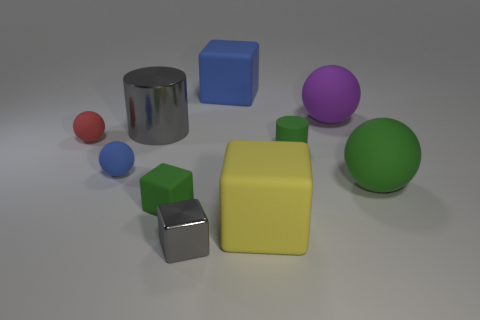Subtract all red balls. How many balls are left? 3 Subtract all gray blocks. How many blocks are left? 3 Subtract all yellow balls. Subtract all brown cylinders. How many balls are left? 4 Subtract all spheres. How many objects are left? 6 Subtract 1 green spheres. How many objects are left? 9 Subtract all purple spheres. Subtract all small cubes. How many objects are left? 7 Add 9 green spheres. How many green spheres are left? 10 Add 4 big cyan rubber things. How many big cyan rubber things exist? 4 